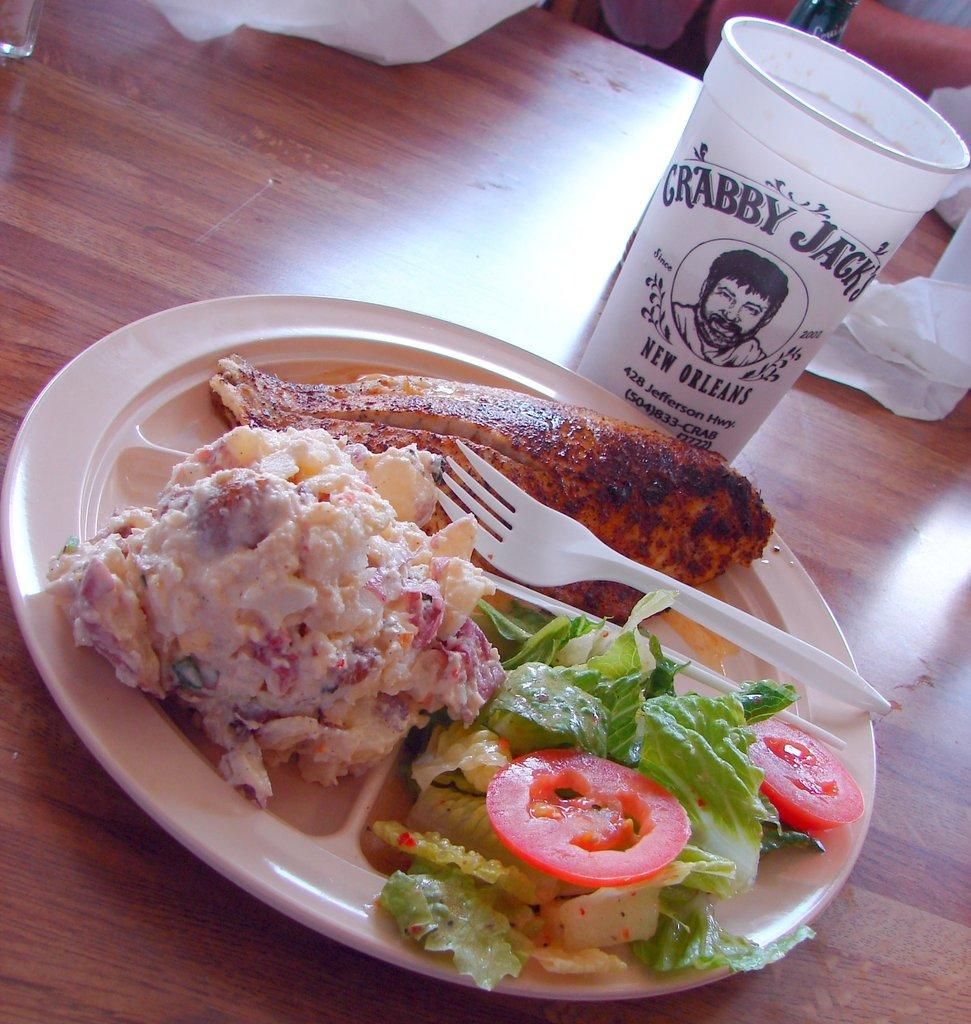What is on the plate that is visible in the image? There is a plate with food in the image. What utensil is visible in the image? There is a fork in the image. What is the glass used for in the image? The glass is used for holding a beverage. What can be used for cleaning or wiping in the image? Tissue papers are present in the image for cleaning or wiping. Where are all of these items located in the image? All of these items are on a table. How many eyes can be seen on the toys in the image? There are no toys present in the image, so there are no eyes to count. 